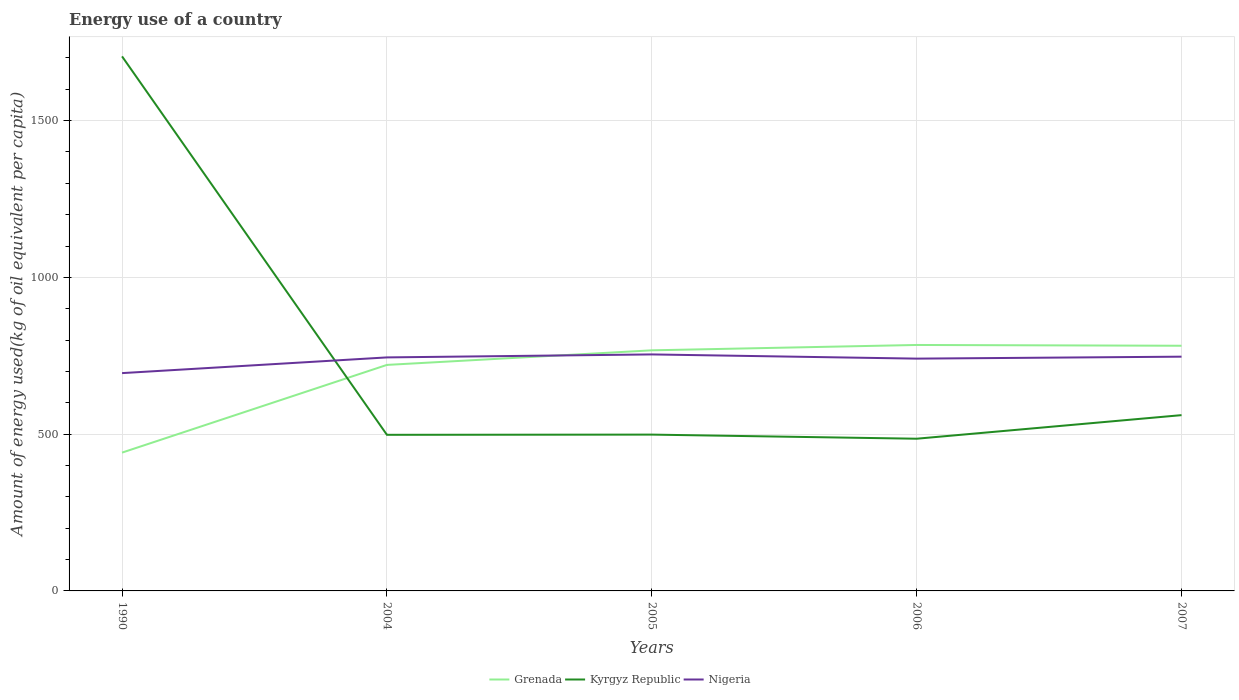How many different coloured lines are there?
Your answer should be very brief. 3. Is the number of lines equal to the number of legend labels?
Provide a short and direct response. Yes. Across all years, what is the maximum amount of energy used in in Grenada?
Give a very brief answer. 441.13. In which year was the amount of energy used in in Grenada maximum?
Ensure brevity in your answer.  1990. What is the total amount of energy used in in Grenada in the graph?
Ensure brevity in your answer.  -63.59. What is the difference between the highest and the second highest amount of energy used in in Grenada?
Give a very brief answer. 343.31. What is the difference between the highest and the lowest amount of energy used in in Nigeria?
Provide a short and direct response. 4. Is the amount of energy used in in Nigeria strictly greater than the amount of energy used in in Kyrgyz Republic over the years?
Offer a terse response. No. How many lines are there?
Give a very brief answer. 3. What is the difference between two consecutive major ticks on the Y-axis?
Offer a terse response. 500. Are the values on the major ticks of Y-axis written in scientific E-notation?
Keep it short and to the point. No. Does the graph contain any zero values?
Offer a very short reply. No. Does the graph contain grids?
Offer a very short reply. Yes. Where does the legend appear in the graph?
Offer a very short reply. Bottom center. How are the legend labels stacked?
Your response must be concise. Horizontal. What is the title of the graph?
Provide a short and direct response. Energy use of a country. Does "West Bank and Gaza" appear as one of the legend labels in the graph?
Your response must be concise. No. What is the label or title of the X-axis?
Keep it short and to the point. Years. What is the label or title of the Y-axis?
Offer a very short reply. Amount of energy used(kg of oil equivalent per capita). What is the Amount of energy used(kg of oil equivalent per capita) in Grenada in 1990?
Your response must be concise. 441.13. What is the Amount of energy used(kg of oil equivalent per capita) in Kyrgyz Republic in 1990?
Your answer should be very brief. 1704.81. What is the Amount of energy used(kg of oil equivalent per capita) of Nigeria in 1990?
Offer a terse response. 694.66. What is the Amount of energy used(kg of oil equivalent per capita) in Grenada in 2004?
Ensure brevity in your answer.  720.85. What is the Amount of energy used(kg of oil equivalent per capita) in Kyrgyz Republic in 2004?
Your response must be concise. 497.87. What is the Amount of energy used(kg of oil equivalent per capita) of Nigeria in 2004?
Keep it short and to the point. 744.75. What is the Amount of energy used(kg of oil equivalent per capita) in Grenada in 2005?
Ensure brevity in your answer.  767.36. What is the Amount of energy used(kg of oil equivalent per capita) of Kyrgyz Republic in 2005?
Make the answer very short. 498.54. What is the Amount of energy used(kg of oil equivalent per capita) of Nigeria in 2005?
Provide a short and direct response. 754.26. What is the Amount of energy used(kg of oil equivalent per capita) in Grenada in 2006?
Your answer should be compact. 784.44. What is the Amount of energy used(kg of oil equivalent per capita) of Kyrgyz Republic in 2006?
Provide a succinct answer. 485.42. What is the Amount of energy used(kg of oil equivalent per capita) of Nigeria in 2006?
Offer a terse response. 740.88. What is the Amount of energy used(kg of oil equivalent per capita) of Grenada in 2007?
Your response must be concise. 781.95. What is the Amount of energy used(kg of oil equivalent per capita) in Kyrgyz Republic in 2007?
Your response must be concise. 560.62. What is the Amount of energy used(kg of oil equivalent per capita) of Nigeria in 2007?
Ensure brevity in your answer.  747.1. Across all years, what is the maximum Amount of energy used(kg of oil equivalent per capita) in Grenada?
Provide a short and direct response. 784.44. Across all years, what is the maximum Amount of energy used(kg of oil equivalent per capita) of Kyrgyz Republic?
Make the answer very short. 1704.81. Across all years, what is the maximum Amount of energy used(kg of oil equivalent per capita) in Nigeria?
Your answer should be compact. 754.26. Across all years, what is the minimum Amount of energy used(kg of oil equivalent per capita) in Grenada?
Offer a terse response. 441.13. Across all years, what is the minimum Amount of energy used(kg of oil equivalent per capita) of Kyrgyz Republic?
Provide a succinct answer. 485.42. Across all years, what is the minimum Amount of energy used(kg of oil equivalent per capita) in Nigeria?
Keep it short and to the point. 694.66. What is the total Amount of energy used(kg of oil equivalent per capita) in Grenada in the graph?
Provide a succinct answer. 3495.72. What is the total Amount of energy used(kg of oil equivalent per capita) of Kyrgyz Republic in the graph?
Make the answer very short. 3747.26. What is the total Amount of energy used(kg of oil equivalent per capita) of Nigeria in the graph?
Keep it short and to the point. 3681.64. What is the difference between the Amount of energy used(kg of oil equivalent per capita) in Grenada in 1990 and that in 2004?
Your response must be concise. -279.72. What is the difference between the Amount of energy used(kg of oil equivalent per capita) of Kyrgyz Republic in 1990 and that in 2004?
Your answer should be compact. 1206.95. What is the difference between the Amount of energy used(kg of oil equivalent per capita) of Nigeria in 1990 and that in 2004?
Offer a very short reply. -50.09. What is the difference between the Amount of energy used(kg of oil equivalent per capita) in Grenada in 1990 and that in 2005?
Offer a terse response. -326.23. What is the difference between the Amount of energy used(kg of oil equivalent per capita) in Kyrgyz Republic in 1990 and that in 2005?
Your answer should be very brief. 1206.27. What is the difference between the Amount of energy used(kg of oil equivalent per capita) of Nigeria in 1990 and that in 2005?
Your response must be concise. -59.6. What is the difference between the Amount of energy used(kg of oil equivalent per capita) in Grenada in 1990 and that in 2006?
Your answer should be compact. -343.31. What is the difference between the Amount of energy used(kg of oil equivalent per capita) of Kyrgyz Republic in 1990 and that in 2006?
Provide a succinct answer. 1219.4. What is the difference between the Amount of energy used(kg of oil equivalent per capita) in Nigeria in 1990 and that in 2006?
Ensure brevity in your answer.  -46.22. What is the difference between the Amount of energy used(kg of oil equivalent per capita) of Grenada in 1990 and that in 2007?
Provide a short and direct response. -340.82. What is the difference between the Amount of energy used(kg of oil equivalent per capita) of Kyrgyz Republic in 1990 and that in 2007?
Offer a terse response. 1144.2. What is the difference between the Amount of energy used(kg of oil equivalent per capita) in Nigeria in 1990 and that in 2007?
Your answer should be very brief. -52.44. What is the difference between the Amount of energy used(kg of oil equivalent per capita) of Grenada in 2004 and that in 2005?
Your response must be concise. -46.51. What is the difference between the Amount of energy used(kg of oil equivalent per capita) of Kyrgyz Republic in 2004 and that in 2005?
Make the answer very short. -0.67. What is the difference between the Amount of energy used(kg of oil equivalent per capita) in Nigeria in 2004 and that in 2005?
Your response must be concise. -9.51. What is the difference between the Amount of energy used(kg of oil equivalent per capita) of Grenada in 2004 and that in 2006?
Your response must be concise. -63.59. What is the difference between the Amount of energy used(kg of oil equivalent per capita) in Kyrgyz Republic in 2004 and that in 2006?
Your response must be concise. 12.45. What is the difference between the Amount of energy used(kg of oil equivalent per capita) in Nigeria in 2004 and that in 2006?
Keep it short and to the point. 3.86. What is the difference between the Amount of energy used(kg of oil equivalent per capita) of Grenada in 2004 and that in 2007?
Your response must be concise. -61.1. What is the difference between the Amount of energy used(kg of oil equivalent per capita) of Kyrgyz Republic in 2004 and that in 2007?
Provide a succinct answer. -62.75. What is the difference between the Amount of energy used(kg of oil equivalent per capita) of Nigeria in 2004 and that in 2007?
Give a very brief answer. -2.36. What is the difference between the Amount of energy used(kg of oil equivalent per capita) in Grenada in 2005 and that in 2006?
Provide a short and direct response. -17.08. What is the difference between the Amount of energy used(kg of oil equivalent per capita) of Kyrgyz Republic in 2005 and that in 2006?
Your answer should be very brief. 13.12. What is the difference between the Amount of energy used(kg of oil equivalent per capita) in Nigeria in 2005 and that in 2006?
Offer a very short reply. 13.37. What is the difference between the Amount of energy used(kg of oil equivalent per capita) in Grenada in 2005 and that in 2007?
Provide a succinct answer. -14.6. What is the difference between the Amount of energy used(kg of oil equivalent per capita) in Kyrgyz Republic in 2005 and that in 2007?
Provide a short and direct response. -62.08. What is the difference between the Amount of energy used(kg of oil equivalent per capita) in Nigeria in 2005 and that in 2007?
Provide a succinct answer. 7.16. What is the difference between the Amount of energy used(kg of oil equivalent per capita) of Grenada in 2006 and that in 2007?
Make the answer very short. 2.48. What is the difference between the Amount of energy used(kg of oil equivalent per capita) in Kyrgyz Republic in 2006 and that in 2007?
Offer a terse response. -75.2. What is the difference between the Amount of energy used(kg of oil equivalent per capita) in Nigeria in 2006 and that in 2007?
Offer a terse response. -6.22. What is the difference between the Amount of energy used(kg of oil equivalent per capita) of Grenada in 1990 and the Amount of energy used(kg of oil equivalent per capita) of Kyrgyz Republic in 2004?
Provide a succinct answer. -56.74. What is the difference between the Amount of energy used(kg of oil equivalent per capita) of Grenada in 1990 and the Amount of energy used(kg of oil equivalent per capita) of Nigeria in 2004?
Provide a succinct answer. -303.62. What is the difference between the Amount of energy used(kg of oil equivalent per capita) in Kyrgyz Republic in 1990 and the Amount of energy used(kg of oil equivalent per capita) in Nigeria in 2004?
Ensure brevity in your answer.  960.07. What is the difference between the Amount of energy used(kg of oil equivalent per capita) in Grenada in 1990 and the Amount of energy used(kg of oil equivalent per capita) in Kyrgyz Republic in 2005?
Offer a very short reply. -57.42. What is the difference between the Amount of energy used(kg of oil equivalent per capita) of Grenada in 1990 and the Amount of energy used(kg of oil equivalent per capita) of Nigeria in 2005?
Give a very brief answer. -313.13. What is the difference between the Amount of energy used(kg of oil equivalent per capita) of Kyrgyz Republic in 1990 and the Amount of energy used(kg of oil equivalent per capita) of Nigeria in 2005?
Ensure brevity in your answer.  950.56. What is the difference between the Amount of energy used(kg of oil equivalent per capita) of Grenada in 1990 and the Amount of energy used(kg of oil equivalent per capita) of Kyrgyz Republic in 2006?
Offer a very short reply. -44.29. What is the difference between the Amount of energy used(kg of oil equivalent per capita) of Grenada in 1990 and the Amount of energy used(kg of oil equivalent per capita) of Nigeria in 2006?
Ensure brevity in your answer.  -299.75. What is the difference between the Amount of energy used(kg of oil equivalent per capita) of Kyrgyz Republic in 1990 and the Amount of energy used(kg of oil equivalent per capita) of Nigeria in 2006?
Ensure brevity in your answer.  963.93. What is the difference between the Amount of energy used(kg of oil equivalent per capita) in Grenada in 1990 and the Amount of energy used(kg of oil equivalent per capita) in Kyrgyz Republic in 2007?
Offer a very short reply. -119.49. What is the difference between the Amount of energy used(kg of oil equivalent per capita) in Grenada in 1990 and the Amount of energy used(kg of oil equivalent per capita) in Nigeria in 2007?
Your answer should be very brief. -305.97. What is the difference between the Amount of energy used(kg of oil equivalent per capita) in Kyrgyz Republic in 1990 and the Amount of energy used(kg of oil equivalent per capita) in Nigeria in 2007?
Make the answer very short. 957.71. What is the difference between the Amount of energy used(kg of oil equivalent per capita) of Grenada in 2004 and the Amount of energy used(kg of oil equivalent per capita) of Kyrgyz Republic in 2005?
Your response must be concise. 222.3. What is the difference between the Amount of energy used(kg of oil equivalent per capita) of Grenada in 2004 and the Amount of energy used(kg of oil equivalent per capita) of Nigeria in 2005?
Your response must be concise. -33.41. What is the difference between the Amount of energy used(kg of oil equivalent per capita) in Kyrgyz Republic in 2004 and the Amount of energy used(kg of oil equivalent per capita) in Nigeria in 2005?
Your answer should be very brief. -256.39. What is the difference between the Amount of energy used(kg of oil equivalent per capita) in Grenada in 2004 and the Amount of energy used(kg of oil equivalent per capita) in Kyrgyz Republic in 2006?
Your response must be concise. 235.43. What is the difference between the Amount of energy used(kg of oil equivalent per capita) in Grenada in 2004 and the Amount of energy used(kg of oil equivalent per capita) in Nigeria in 2006?
Keep it short and to the point. -20.03. What is the difference between the Amount of energy used(kg of oil equivalent per capita) in Kyrgyz Republic in 2004 and the Amount of energy used(kg of oil equivalent per capita) in Nigeria in 2006?
Your response must be concise. -243.01. What is the difference between the Amount of energy used(kg of oil equivalent per capita) in Grenada in 2004 and the Amount of energy used(kg of oil equivalent per capita) in Kyrgyz Republic in 2007?
Give a very brief answer. 160.23. What is the difference between the Amount of energy used(kg of oil equivalent per capita) of Grenada in 2004 and the Amount of energy used(kg of oil equivalent per capita) of Nigeria in 2007?
Offer a terse response. -26.25. What is the difference between the Amount of energy used(kg of oil equivalent per capita) in Kyrgyz Republic in 2004 and the Amount of energy used(kg of oil equivalent per capita) in Nigeria in 2007?
Your answer should be compact. -249.23. What is the difference between the Amount of energy used(kg of oil equivalent per capita) in Grenada in 2005 and the Amount of energy used(kg of oil equivalent per capita) in Kyrgyz Republic in 2006?
Make the answer very short. 281.94. What is the difference between the Amount of energy used(kg of oil equivalent per capita) in Grenada in 2005 and the Amount of energy used(kg of oil equivalent per capita) in Nigeria in 2006?
Keep it short and to the point. 26.47. What is the difference between the Amount of energy used(kg of oil equivalent per capita) of Kyrgyz Republic in 2005 and the Amount of energy used(kg of oil equivalent per capita) of Nigeria in 2006?
Keep it short and to the point. -242.34. What is the difference between the Amount of energy used(kg of oil equivalent per capita) of Grenada in 2005 and the Amount of energy used(kg of oil equivalent per capita) of Kyrgyz Republic in 2007?
Keep it short and to the point. 206.74. What is the difference between the Amount of energy used(kg of oil equivalent per capita) in Grenada in 2005 and the Amount of energy used(kg of oil equivalent per capita) in Nigeria in 2007?
Keep it short and to the point. 20.25. What is the difference between the Amount of energy used(kg of oil equivalent per capita) of Kyrgyz Republic in 2005 and the Amount of energy used(kg of oil equivalent per capita) of Nigeria in 2007?
Your response must be concise. -248.56. What is the difference between the Amount of energy used(kg of oil equivalent per capita) in Grenada in 2006 and the Amount of energy used(kg of oil equivalent per capita) in Kyrgyz Republic in 2007?
Give a very brief answer. 223.82. What is the difference between the Amount of energy used(kg of oil equivalent per capita) in Grenada in 2006 and the Amount of energy used(kg of oil equivalent per capita) in Nigeria in 2007?
Offer a very short reply. 37.33. What is the difference between the Amount of energy used(kg of oil equivalent per capita) of Kyrgyz Republic in 2006 and the Amount of energy used(kg of oil equivalent per capita) of Nigeria in 2007?
Your answer should be compact. -261.68. What is the average Amount of energy used(kg of oil equivalent per capita) in Grenada per year?
Your response must be concise. 699.14. What is the average Amount of energy used(kg of oil equivalent per capita) in Kyrgyz Republic per year?
Your answer should be compact. 749.45. What is the average Amount of energy used(kg of oil equivalent per capita) in Nigeria per year?
Keep it short and to the point. 736.33. In the year 1990, what is the difference between the Amount of energy used(kg of oil equivalent per capita) of Grenada and Amount of energy used(kg of oil equivalent per capita) of Kyrgyz Republic?
Your answer should be very brief. -1263.69. In the year 1990, what is the difference between the Amount of energy used(kg of oil equivalent per capita) of Grenada and Amount of energy used(kg of oil equivalent per capita) of Nigeria?
Ensure brevity in your answer.  -253.53. In the year 1990, what is the difference between the Amount of energy used(kg of oil equivalent per capita) of Kyrgyz Republic and Amount of energy used(kg of oil equivalent per capita) of Nigeria?
Your response must be concise. 1010.16. In the year 2004, what is the difference between the Amount of energy used(kg of oil equivalent per capita) in Grenada and Amount of energy used(kg of oil equivalent per capita) in Kyrgyz Republic?
Give a very brief answer. 222.98. In the year 2004, what is the difference between the Amount of energy used(kg of oil equivalent per capita) in Grenada and Amount of energy used(kg of oil equivalent per capita) in Nigeria?
Provide a short and direct response. -23.9. In the year 2004, what is the difference between the Amount of energy used(kg of oil equivalent per capita) of Kyrgyz Republic and Amount of energy used(kg of oil equivalent per capita) of Nigeria?
Provide a succinct answer. -246.88. In the year 2005, what is the difference between the Amount of energy used(kg of oil equivalent per capita) in Grenada and Amount of energy used(kg of oil equivalent per capita) in Kyrgyz Republic?
Keep it short and to the point. 268.81. In the year 2005, what is the difference between the Amount of energy used(kg of oil equivalent per capita) in Grenada and Amount of energy used(kg of oil equivalent per capita) in Nigeria?
Make the answer very short. 13.1. In the year 2005, what is the difference between the Amount of energy used(kg of oil equivalent per capita) of Kyrgyz Republic and Amount of energy used(kg of oil equivalent per capita) of Nigeria?
Your answer should be very brief. -255.71. In the year 2006, what is the difference between the Amount of energy used(kg of oil equivalent per capita) in Grenada and Amount of energy used(kg of oil equivalent per capita) in Kyrgyz Republic?
Your response must be concise. 299.02. In the year 2006, what is the difference between the Amount of energy used(kg of oil equivalent per capita) of Grenada and Amount of energy used(kg of oil equivalent per capita) of Nigeria?
Ensure brevity in your answer.  43.55. In the year 2006, what is the difference between the Amount of energy used(kg of oil equivalent per capita) of Kyrgyz Republic and Amount of energy used(kg of oil equivalent per capita) of Nigeria?
Ensure brevity in your answer.  -255.46. In the year 2007, what is the difference between the Amount of energy used(kg of oil equivalent per capita) in Grenada and Amount of energy used(kg of oil equivalent per capita) in Kyrgyz Republic?
Offer a very short reply. 221.33. In the year 2007, what is the difference between the Amount of energy used(kg of oil equivalent per capita) in Grenada and Amount of energy used(kg of oil equivalent per capita) in Nigeria?
Offer a very short reply. 34.85. In the year 2007, what is the difference between the Amount of energy used(kg of oil equivalent per capita) in Kyrgyz Republic and Amount of energy used(kg of oil equivalent per capita) in Nigeria?
Keep it short and to the point. -186.48. What is the ratio of the Amount of energy used(kg of oil equivalent per capita) of Grenada in 1990 to that in 2004?
Provide a short and direct response. 0.61. What is the ratio of the Amount of energy used(kg of oil equivalent per capita) in Kyrgyz Republic in 1990 to that in 2004?
Make the answer very short. 3.42. What is the ratio of the Amount of energy used(kg of oil equivalent per capita) in Nigeria in 1990 to that in 2004?
Make the answer very short. 0.93. What is the ratio of the Amount of energy used(kg of oil equivalent per capita) of Grenada in 1990 to that in 2005?
Your response must be concise. 0.57. What is the ratio of the Amount of energy used(kg of oil equivalent per capita) in Kyrgyz Republic in 1990 to that in 2005?
Your answer should be compact. 3.42. What is the ratio of the Amount of energy used(kg of oil equivalent per capita) of Nigeria in 1990 to that in 2005?
Your answer should be compact. 0.92. What is the ratio of the Amount of energy used(kg of oil equivalent per capita) in Grenada in 1990 to that in 2006?
Ensure brevity in your answer.  0.56. What is the ratio of the Amount of energy used(kg of oil equivalent per capita) of Kyrgyz Republic in 1990 to that in 2006?
Offer a very short reply. 3.51. What is the ratio of the Amount of energy used(kg of oil equivalent per capita) in Nigeria in 1990 to that in 2006?
Make the answer very short. 0.94. What is the ratio of the Amount of energy used(kg of oil equivalent per capita) in Grenada in 1990 to that in 2007?
Your answer should be very brief. 0.56. What is the ratio of the Amount of energy used(kg of oil equivalent per capita) of Kyrgyz Republic in 1990 to that in 2007?
Provide a succinct answer. 3.04. What is the ratio of the Amount of energy used(kg of oil equivalent per capita) of Nigeria in 1990 to that in 2007?
Offer a terse response. 0.93. What is the ratio of the Amount of energy used(kg of oil equivalent per capita) of Grenada in 2004 to that in 2005?
Offer a terse response. 0.94. What is the ratio of the Amount of energy used(kg of oil equivalent per capita) of Nigeria in 2004 to that in 2005?
Give a very brief answer. 0.99. What is the ratio of the Amount of energy used(kg of oil equivalent per capita) of Grenada in 2004 to that in 2006?
Offer a very short reply. 0.92. What is the ratio of the Amount of energy used(kg of oil equivalent per capita) of Kyrgyz Republic in 2004 to that in 2006?
Provide a succinct answer. 1.03. What is the ratio of the Amount of energy used(kg of oil equivalent per capita) in Grenada in 2004 to that in 2007?
Your answer should be very brief. 0.92. What is the ratio of the Amount of energy used(kg of oil equivalent per capita) in Kyrgyz Republic in 2004 to that in 2007?
Give a very brief answer. 0.89. What is the ratio of the Amount of energy used(kg of oil equivalent per capita) in Grenada in 2005 to that in 2006?
Keep it short and to the point. 0.98. What is the ratio of the Amount of energy used(kg of oil equivalent per capita) of Nigeria in 2005 to that in 2006?
Your answer should be very brief. 1.02. What is the ratio of the Amount of energy used(kg of oil equivalent per capita) in Grenada in 2005 to that in 2007?
Your answer should be very brief. 0.98. What is the ratio of the Amount of energy used(kg of oil equivalent per capita) in Kyrgyz Republic in 2005 to that in 2007?
Keep it short and to the point. 0.89. What is the ratio of the Amount of energy used(kg of oil equivalent per capita) in Nigeria in 2005 to that in 2007?
Your answer should be compact. 1.01. What is the ratio of the Amount of energy used(kg of oil equivalent per capita) of Grenada in 2006 to that in 2007?
Offer a very short reply. 1. What is the ratio of the Amount of energy used(kg of oil equivalent per capita) in Kyrgyz Republic in 2006 to that in 2007?
Provide a succinct answer. 0.87. What is the difference between the highest and the second highest Amount of energy used(kg of oil equivalent per capita) in Grenada?
Keep it short and to the point. 2.48. What is the difference between the highest and the second highest Amount of energy used(kg of oil equivalent per capita) in Kyrgyz Republic?
Give a very brief answer. 1144.2. What is the difference between the highest and the second highest Amount of energy used(kg of oil equivalent per capita) in Nigeria?
Your response must be concise. 7.16. What is the difference between the highest and the lowest Amount of energy used(kg of oil equivalent per capita) of Grenada?
Offer a terse response. 343.31. What is the difference between the highest and the lowest Amount of energy used(kg of oil equivalent per capita) in Kyrgyz Republic?
Your response must be concise. 1219.4. What is the difference between the highest and the lowest Amount of energy used(kg of oil equivalent per capita) of Nigeria?
Your response must be concise. 59.6. 